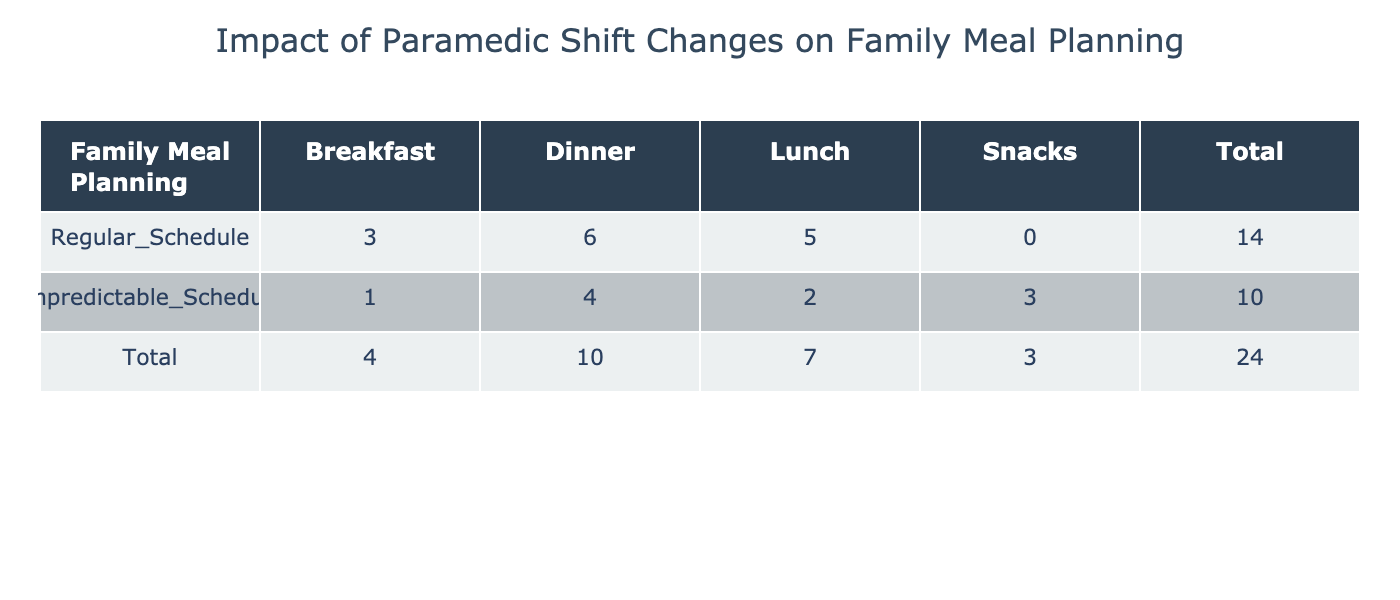What is the total frequency of meals planned under a regular schedule? To find the total frequency of meals planned under a regular schedule, we look for the row with "Regular_Schedule". The frequencies for meals are: Breakfast (3), Lunch (5), and Dinner (6). Summing these gives 3 + 5 + 6 = 14.
Answer: 14 How many different types of meals are prepared when the schedule is unpredictable? The table shows 4 types of meals under "Unpredictable_Schedule": Breakfast, Lunch, Dinner, and Snacks. Since there are 4 unique meal types listed, the answer is 4.
Answer: 4 What meal requires the longest preparation time, and how much time is needed? In the "Meal_Preparation_Time" section, the meals are categorized by preparation time. The categories are: Under 30 Minutes (4), 30 to 60 Minutes (6), and Over 60 Minutes (2). The category "Over 60 Minutes" indicates that this group is likely to require the longest preparation time, which is more than 60 minutes.
Answer: Over 60 Minutes Is there a meal type that is both vegetarian and takes under 30 minutes to prepare? The vegetarian meal frequency shows that there are 3 vegetarian meals, and under the preparation time, there are 4 meals that take under 30 minutes. However, there are no specific details on whether any of these meals are vegetarian. Therefore, we cannot confirm if a vegetarian meal takes under 30 minutes to prepare, making the answer false.
Answer: No What is the total frequency of meals that take 30 to 60 minutes to prepare? To find this frequency, we look at the "Meal_Preparation_Time" row for "30_to_60_Minutes" category. The table indicates a frequency of 6 meals that fit this preparation time.
Answer: 6 What is the difference in total meal frequency between regular and unpredictable schedules? The total frequency for the regular schedule is 14 (as noted earlier) and for the unpredictable schedule it is 10 (1 for Breakfast, 2 for Lunch, 4 for Dinner, and 3 for Snacks). The difference is calculated by subtracting the total of the unpredictable from that of the regular: 14 - 10 = 4.
Answer: 4 Do more meals require 30 to 60 minutes to prepare than under 30 minutes? Looking at the frequencies, meals that require 30 to 60 minutes total 6, while meals that take under 30 minutes total 4. Since 6 is greater than 4, we can conclude that more meals require 30 to 60 minutes to prepare.
Answer: Yes Which meal type has the highest frequency overall? We have to sum up frequencies for each meal type across all schedules. In total, Breakfast has (3+1=4), Lunch (5+2=7), Dinner (6+4=10), Snacks (3), Vegetarian (3), Non-Vegetarian (7), Quick Recipes (5), and Leftovers (2). The meal type with the highest frequency is Dinner with 10.
Answer: Dinner 